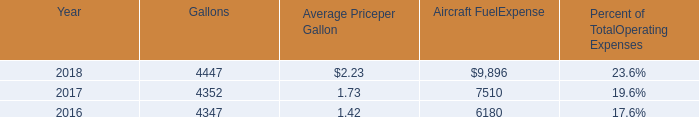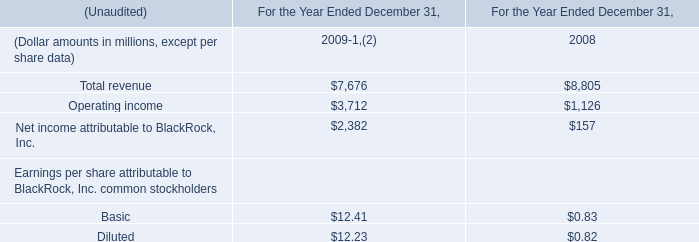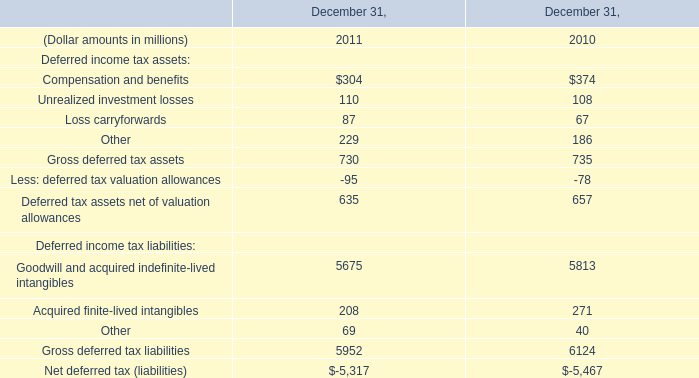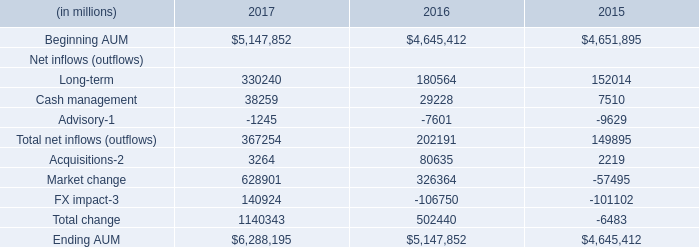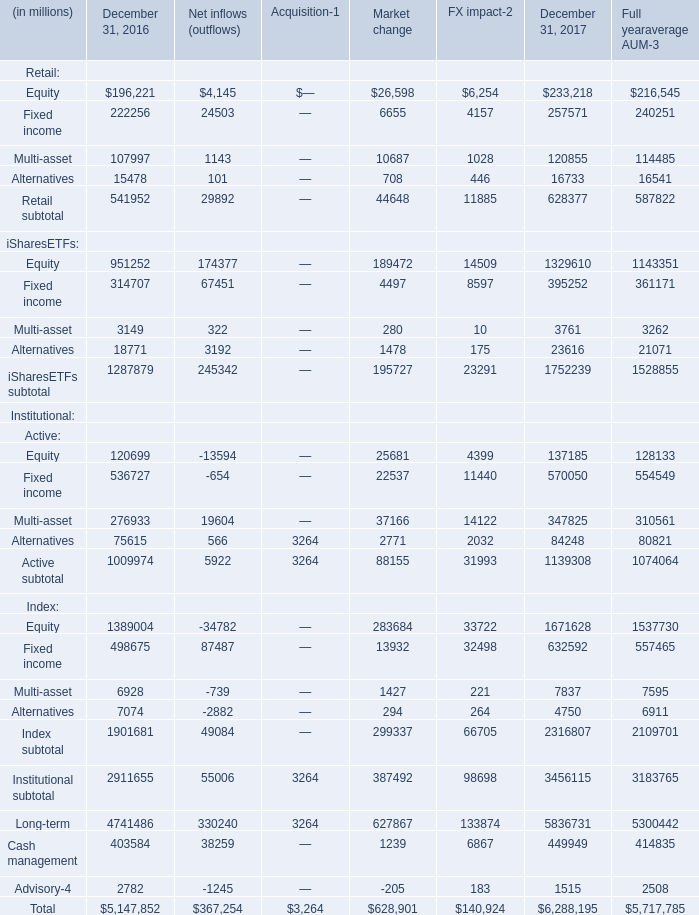What's the total amount of Retail subtotal, iSharesETFs subtotal, Active subtotal and Index subtotal for December 31, 2016? (in dollars in millions) 
Computations: (((541952 + 1287879) + 1009974) + 1901681)
Answer: 4741486.0. 